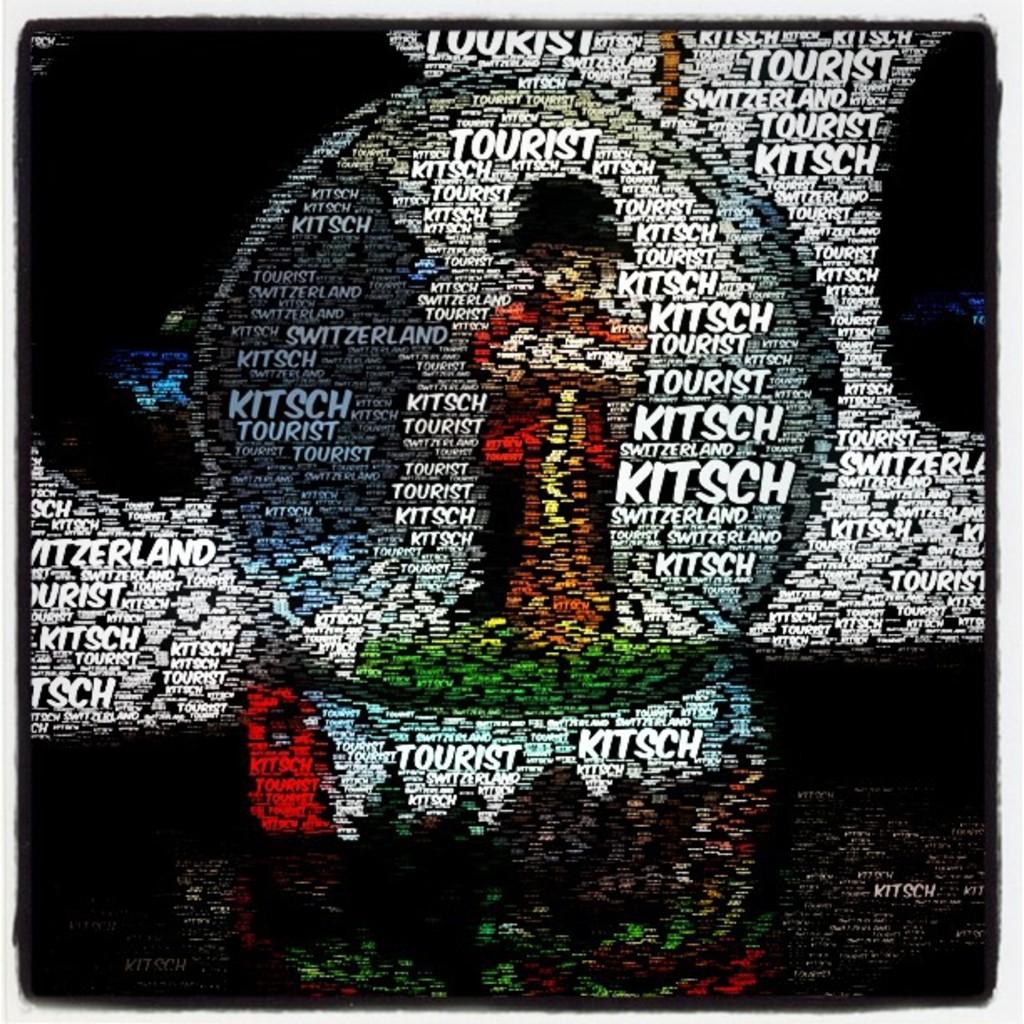What country is listed on the art piece?
Your answer should be compact. Switzerland. What two words are frequently mentioned on this?
Provide a short and direct response. Kitsch tourist. 